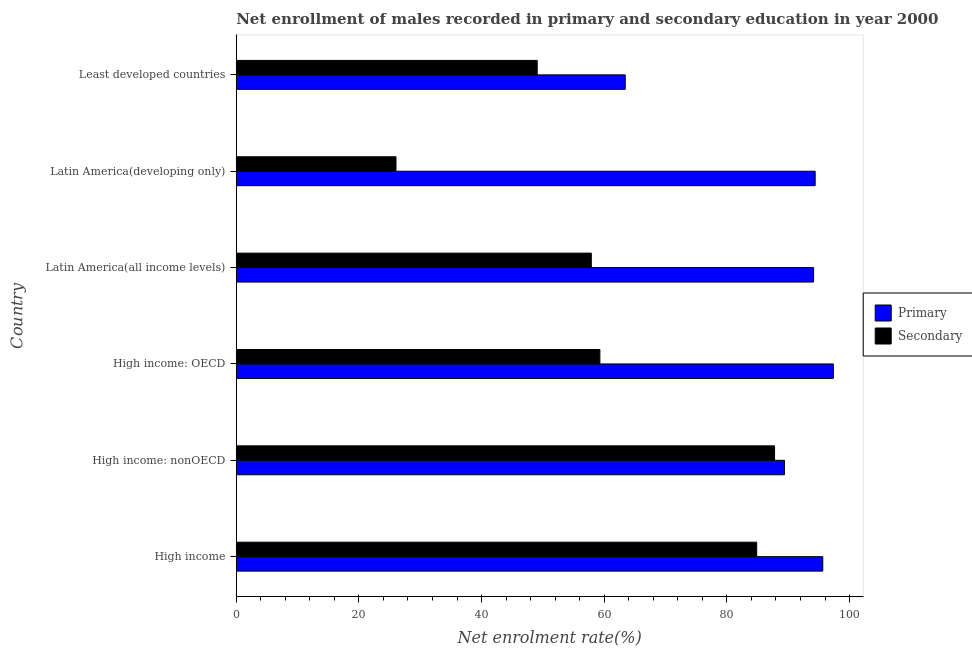How many groups of bars are there?
Offer a terse response. 6. How many bars are there on the 3rd tick from the bottom?
Provide a short and direct response. 2. What is the label of the 4th group of bars from the top?
Your answer should be very brief. High income: OECD. What is the enrollment rate in secondary education in Least developed countries?
Your answer should be compact. 49.07. Across all countries, what is the maximum enrollment rate in secondary education?
Offer a terse response. 87.77. Across all countries, what is the minimum enrollment rate in primary education?
Your response must be concise. 63.42. In which country was the enrollment rate in secondary education maximum?
Offer a terse response. High income: nonOECD. In which country was the enrollment rate in primary education minimum?
Keep it short and to the point. Least developed countries. What is the total enrollment rate in secondary education in the graph?
Ensure brevity in your answer.  364.93. What is the difference between the enrollment rate in primary education in High income: nonOECD and that in Least developed countries?
Your answer should be very brief. 25.95. What is the difference between the enrollment rate in secondary education in Least developed countries and the enrollment rate in primary education in Latin America(all income levels)?
Your answer should be very brief. -45.07. What is the average enrollment rate in primary education per country?
Keep it short and to the point. 89.05. What is the difference between the enrollment rate in primary education and enrollment rate in secondary education in Latin America(developing only)?
Provide a succinct answer. 68.35. In how many countries, is the enrollment rate in secondary education greater than 64 %?
Offer a very short reply. 2. What is the ratio of the enrollment rate in primary education in High income: OECD to that in Least developed countries?
Your response must be concise. 1.53. Is the enrollment rate in primary education in High income: nonOECD less than that in Latin America(all income levels)?
Give a very brief answer. Yes. Is the difference between the enrollment rate in secondary education in High income: nonOECD and Latin America(all income levels) greater than the difference between the enrollment rate in primary education in High income: nonOECD and Latin America(all income levels)?
Keep it short and to the point. Yes. What is the difference between the highest and the second highest enrollment rate in primary education?
Your response must be concise. 1.72. What is the difference between the highest and the lowest enrollment rate in primary education?
Your answer should be very brief. 33.94. Is the sum of the enrollment rate in primary education in High income and Latin America(developing only) greater than the maximum enrollment rate in secondary education across all countries?
Give a very brief answer. Yes. What does the 1st bar from the top in Latin America(all income levels) represents?
Provide a short and direct response. Secondary. What does the 2nd bar from the bottom in Least developed countries represents?
Your response must be concise. Secondary. How many bars are there?
Provide a short and direct response. 12. Are all the bars in the graph horizontal?
Keep it short and to the point. Yes. How many countries are there in the graph?
Your answer should be very brief. 6. Are the values on the major ticks of X-axis written in scientific E-notation?
Offer a terse response. No. Does the graph contain any zero values?
Your answer should be very brief. No. Where does the legend appear in the graph?
Offer a very short reply. Center right. What is the title of the graph?
Your answer should be very brief. Net enrollment of males recorded in primary and secondary education in year 2000. Does "International Tourists" appear as one of the legend labels in the graph?
Your answer should be very brief. No. What is the label or title of the X-axis?
Offer a terse response. Net enrolment rate(%). What is the label or title of the Y-axis?
Ensure brevity in your answer.  Country. What is the Net enrolment rate(%) of Primary in High income?
Your answer should be very brief. 95.63. What is the Net enrolment rate(%) of Secondary in High income?
Ensure brevity in your answer.  84.86. What is the Net enrolment rate(%) in Primary in High income: nonOECD?
Provide a succinct answer. 89.38. What is the Net enrolment rate(%) of Secondary in High income: nonOECD?
Make the answer very short. 87.77. What is the Net enrolment rate(%) of Primary in High income: OECD?
Make the answer very short. 97.36. What is the Net enrolment rate(%) of Secondary in High income: OECD?
Your answer should be compact. 59.29. What is the Net enrolment rate(%) of Primary in Latin America(all income levels)?
Offer a very short reply. 94.14. What is the Net enrolment rate(%) of Secondary in Latin America(all income levels)?
Provide a succinct answer. 57.89. What is the Net enrolment rate(%) in Primary in Latin America(developing only)?
Ensure brevity in your answer.  94.39. What is the Net enrolment rate(%) in Secondary in Latin America(developing only)?
Your response must be concise. 26.05. What is the Net enrolment rate(%) of Primary in Least developed countries?
Offer a terse response. 63.42. What is the Net enrolment rate(%) in Secondary in Least developed countries?
Your answer should be very brief. 49.07. Across all countries, what is the maximum Net enrolment rate(%) in Primary?
Ensure brevity in your answer.  97.36. Across all countries, what is the maximum Net enrolment rate(%) of Secondary?
Make the answer very short. 87.77. Across all countries, what is the minimum Net enrolment rate(%) of Primary?
Offer a very short reply. 63.42. Across all countries, what is the minimum Net enrolment rate(%) in Secondary?
Ensure brevity in your answer.  26.05. What is the total Net enrolment rate(%) in Primary in the graph?
Provide a succinct answer. 534.32. What is the total Net enrolment rate(%) in Secondary in the graph?
Ensure brevity in your answer.  364.93. What is the difference between the Net enrolment rate(%) in Primary in High income and that in High income: nonOECD?
Provide a succinct answer. 6.26. What is the difference between the Net enrolment rate(%) in Secondary in High income and that in High income: nonOECD?
Your response must be concise. -2.91. What is the difference between the Net enrolment rate(%) of Primary in High income and that in High income: OECD?
Offer a very short reply. -1.72. What is the difference between the Net enrolment rate(%) of Secondary in High income and that in High income: OECD?
Ensure brevity in your answer.  25.57. What is the difference between the Net enrolment rate(%) in Primary in High income and that in Latin America(all income levels)?
Ensure brevity in your answer.  1.5. What is the difference between the Net enrolment rate(%) of Secondary in High income and that in Latin America(all income levels)?
Provide a short and direct response. 26.97. What is the difference between the Net enrolment rate(%) in Primary in High income and that in Latin America(developing only)?
Give a very brief answer. 1.24. What is the difference between the Net enrolment rate(%) of Secondary in High income and that in Latin America(developing only)?
Provide a short and direct response. 58.82. What is the difference between the Net enrolment rate(%) in Primary in High income and that in Least developed countries?
Offer a very short reply. 32.21. What is the difference between the Net enrolment rate(%) of Secondary in High income and that in Least developed countries?
Offer a very short reply. 35.79. What is the difference between the Net enrolment rate(%) of Primary in High income: nonOECD and that in High income: OECD?
Make the answer very short. -7.98. What is the difference between the Net enrolment rate(%) in Secondary in High income: nonOECD and that in High income: OECD?
Make the answer very short. 28.48. What is the difference between the Net enrolment rate(%) in Primary in High income: nonOECD and that in Latin America(all income levels)?
Your response must be concise. -4.76. What is the difference between the Net enrolment rate(%) of Secondary in High income: nonOECD and that in Latin America(all income levels)?
Your response must be concise. 29.88. What is the difference between the Net enrolment rate(%) in Primary in High income: nonOECD and that in Latin America(developing only)?
Offer a very short reply. -5.01. What is the difference between the Net enrolment rate(%) of Secondary in High income: nonOECD and that in Latin America(developing only)?
Offer a terse response. 61.73. What is the difference between the Net enrolment rate(%) in Primary in High income: nonOECD and that in Least developed countries?
Your response must be concise. 25.95. What is the difference between the Net enrolment rate(%) in Secondary in High income: nonOECD and that in Least developed countries?
Provide a short and direct response. 38.7. What is the difference between the Net enrolment rate(%) in Primary in High income: OECD and that in Latin America(all income levels)?
Your response must be concise. 3.22. What is the difference between the Net enrolment rate(%) in Secondary in High income: OECD and that in Latin America(all income levels)?
Offer a very short reply. 1.4. What is the difference between the Net enrolment rate(%) of Primary in High income: OECD and that in Latin America(developing only)?
Keep it short and to the point. 2.97. What is the difference between the Net enrolment rate(%) in Secondary in High income: OECD and that in Latin America(developing only)?
Offer a very short reply. 33.25. What is the difference between the Net enrolment rate(%) in Primary in High income: OECD and that in Least developed countries?
Ensure brevity in your answer.  33.94. What is the difference between the Net enrolment rate(%) in Secondary in High income: OECD and that in Least developed countries?
Make the answer very short. 10.22. What is the difference between the Net enrolment rate(%) in Primary in Latin America(all income levels) and that in Latin America(developing only)?
Offer a very short reply. -0.26. What is the difference between the Net enrolment rate(%) in Secondary in Latin America(all income levels) and that in Latin America(developing only)?
Keep it short and to the point. 31.85. What is the difference between the Net enrolment rate(%) in Primary in Latin America(all income levels) and that in Least developed countries?
Keep it short and to the point. 30.71. What is the difference between the Net enrolment rate(%) of Secondary in Latin America(all income levels) and that in Least developed countries?
Your answer should be very brief. 8.82. What is the difference between the Net enrolment rate(%) in Primary in Latin America(developing only) and that in Least developed countries?
Give a very brief answer. 30.97. What is the difference between the Net enrolment rate(%) in Secondary in Latin America(developing only) and that in Least developed countries?
Make the answer very short. -23.02. What is the difference between the Net enrolment rate(%) of Primary in High income and the Net enrolment rate(%) of Secondary in High income: nonOECD?
Provide a short and direct response. 7.86. What is the difference between the Net enrolment rate(%) of Primary in High income and the Net enrolment rate(%) of Secondary in High income: OECD?
Keep it short and to the point. 36.34. What is the difference between the Net enrolment rate(%) in Primary in High income and the Net enrolment rate(%) in Secondary in Latin America(all income levels)?
Your response must be concise. 37.74. What is the difference between the Net enrolment rate(%) in Primary in High income and the Net enrolment rate(%) in Secondary in Latin America(developing only)?
Offer a very short reply. 69.59. What is the difference between the Net enrolment rate(%) of Primary in High income and the Net enrolment rate(%) of Secondary in Least developed countries?
Your answer should be compact. 46.57. What is the difference between the Net enrolment rate(%) in Primary in High income: nonOECD and the Net enrolment rate(%) in Secondary in High income: OECD?
Your answer should be very brief. 30.09. What is the difference between the Net enrolment rate(%) of Primary in High income: nonOECD and the Net enrolment rate(%) of Secondary in Latin America(all income levels)?
Give a very brief answer. 31.49. What is the difference between the Net enrolment rate(%) of Primary in High income: nonOECD and the Net enrolment rate(%) of Secondary in Latin America(developing only)?
Your answer should be very brief. 63.33. What is the difference between the Net enrolment rate(%) of Primary in High income: nonOECD and the Net enrolment rate(%) of Secondary in Least developed countries?
Offer a very short reply. 40.31. What is the difference between the Net enrolment rate(%) in Primary in High income: OECD and the Net enrolment rate(%) in Secondary in Latin America(all income levels)?
Offer a terse response. 39.47. What is the difference between the Net enrolment rate(%) of Primary in High income: OECD and the Net enrolment rate(%) of Secondary in Latin America(developing only)?
Offer a very short reply. 71.31. What is the difference between the Net enrolment rate(%) in Primary in High income: OECD and the Net enrolment rate(%) in Secondary in Least developed countries?
Offer a very short reply. 48.29. What is the difference between the Net enrolment rate(%) of Primary in Latin America(all income levels) and the Net enrolment rate(%) of Secondary in Latin America(developing only)?
Your answer should be very brief. 68.09. What is the difference between the Net enrolment rate(%) in Primary in Latin America(all income levels) and the Net enrolment rate(%) in Secondary in Least developed countries?
Offer a terse response. 45.07. What is the difference between the Net enrolment rate(%) of Primary in Latin America(developing only) and the Net enrolment rate(%) of Secondary in Least developed countries?
Ensure brevity in your answer.  45.32. What is the average Net enrolment rate(%) in Primary per country?
Provide a succinct answer. 89.05. What is the average Net enrolment rate(%) in Secondary per country?
Provide a succinct answer. 60.82. What is the difference between the Net enrolment rate(%) of Primary and Net enrolment rate(%) of Secondary in High income?
Your answer should be compact. 10.77. What is the difference between the Net enrolment rate(%) of Primary and Net enrolment rate(%) of Secondary in High income: nonOECD?
Offer a terse response. 1.6. What is the difference between the Net enrolment rate(%) in Primary and Net enrolment rate(%) in Secondary in High income: OECD?
Keep it short and to the point. 38.07. What is the difference between the Net enrolment rate(%) in Primary and Net enrolment rate(%) in Secondary in Latin America(all income levels)?
Your response must be concise. 36.24. What is the difference between the Net enrolment rate(%) in Primary and Net enrolment rate(%) in Secondary in Latin America(developing only)?
Give a very brief answer. 68.35. What is the difference between the Net enrolment rate(%) of Primary and Net enrolment rate(%) of Secondary in Least developed countries?
Your answer should be very brief. 14.35. What is the ratio of the Net enrolment rate(%) of Primary in High income to that in High income: nonOECD?
Offer a terse response. 1.07. What is the ratio of the Net enrolment rate(%) in Secondary in High income to that in High income: nonOECD?
Provide a succinct answer. 0.97. What is the ratio of the Net enrolment rate(%) in Primary in High income to that in High income: OECD?
Offer a very short reply. 0.98. What is the ratio of the Net enrolment rate(%) in Secondary in High income to that in High income: OECD?
Provide a short and direct response. 1.43. What is the ratio of the Net enrolment rate(%) in Primary in High income to that in Latin America(all income levels)?
Provide a short and direct response. 1.02. What is the ratio of the Net enrolment rate(%) in Secondary in High income to that in Latin America(all income levels)?
Give a very brief answer. 1.47. What is the ratio of the Net enrolment rate(%) in Primary in High income to that in Latin America(developing only)?
Provide a short and direct response. 1.01. What is the ratio of the Net enrolment rate(%) of Secondary in High income to that in Latin America(developing only)?
Provide a succinct answer. 3.26. What is the ratio of the Net enrolment rate(%) of Primary in High income to that in Least developed countries?
Your response must be concise. 1.51. What is the ratio of the Net enrolment rate(%) in Secondary in High income to that in Least developed countries?
Keep it short and to the point. 1.73. What is the ratio of the Net enrolment rate(%) in Primary in High income: nonOECD to that in High income: OECD?
Make the answer very short. 0.92. What is the ratio of the Net enrolment rate(%) in Secondary in High income: nonOECD to that in High income: OECD?
Your answer should be compact. 1.48. What is the ratio of the Net enrolment rate(%) in Primary in High income: nonOECD to that in Latin America(all income levels)?
Your answer should be compact. 0.95. What is the ratio of the Net enrolment rate(%) in Secondary in High income: nonOECD to that in Latin America(all income levels)?
Your answer should be compact. 1.52. What is the ratio of the Net enrolment rate(%) of Primary in High income: nonOECD to that in Latin America(developing only)?
Your answer should be compact. 0.95. What is the ratio of the Net enrolment rate(%) of Secondary in High income: nonOECD to that in Latin America(developing only)?
Keep it short and to the point. 3.37. What is the ratio of the Net enrolment rate(%) in Primary in High income: nonOECD to that in Least developed countries?
Ensure brevity in your answer.  1.41. What is the ratio of the Net enrolment rate(%) of Secondary in High income: nonOECD to that in Least developed countries?
Give a very brief answer. 1.79. What is the ratio of the Net enrolment rate(%) of Primary in High income: OECD to that in Latin America(all income levels)?
Your response must be concise. 1.03. What is the ratio of the Net enrolment rate(%) of Secondary in High income: OECD to that in Latin America(all income levels)?
Keep it short and to the point. 1.02. What is the ratio of the Net enrolment rate(%) in Primary in High income: OECD to that in Latin America(developing only)?
Provide a short and direct response. 1.03. What is the ratio of the Net enrolment rate(%) in Secondary in High income: OECD to that in Latin America(developing only)?
Offer a terse response. 2.28. What is the ratio of the Net enrolment rate(%) of Primary in High income: OECD to that in Least developed countries?
Your answer should be compact. 1.54. What is the ratio of the Net enrolment rate(%) of Secondary in High income: OECD to that in Least developed countries?
Your answer should be very brief. 1.21. What is the ratio of the Net enrolment rate(%) in Primary in Latin America(all income levels) to that in Latin America(developing only)?
Provide a succinct answer. 1. What is the ratio of the Net enrolment rate(%) in Secondary in Latin America(all income levels) to that in Latin America(developing only)?
Give a very brief answer. 2.22. What is the ratio of the Net enrolment rate(%) in Primary in Latin America(all income levels) to that in Least developed countries?
Offer a terse response. 1.48. What is the ratio of the Net enrolment rate(%) of Secondary in Latin America(all income levels) to that in Least developed countries?
Ensure brevity in your answer.  1.18. What is the ratio of the Net enrolment rate(%) in Primary in Latin America(developing only) to that in Least developed countries?
Ensure brevity in your answer.  1.49. What is the ratio of the Net enrolment rate(%) in Secondary in Latin America(developing only) to that in Least developed countries?
Keep it short and to the point. 0.53. What is the difference between the highest and the second highest Net enrolment rate(%) of Primary?
Offer a terse response. 1.72. What is the difference between the highest and the second highest Net enrolment rate(%) in Secondary?
Your response must be concise. 2.91. What is the difference between the highest and the lowest Net enrolment rate(%) in Primary?
Your answer should be compact. 33.94. What is the difference between the highest and the lowest Net enrolment rate(%) of Secondary?
Provide a short and direct response. 61.73. 